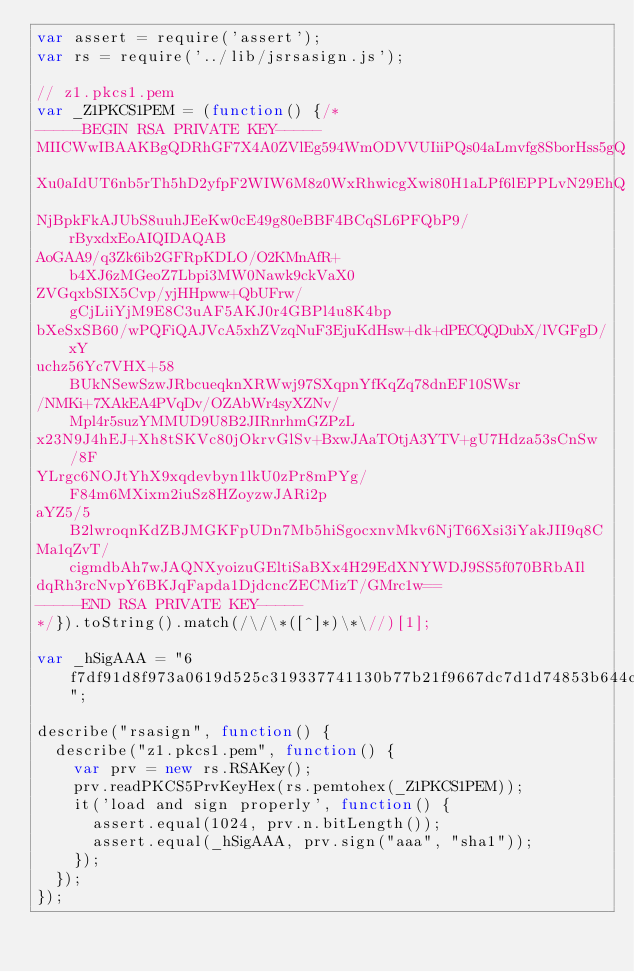<code> <loc_0><loc_0><loc_500><loc_500><_JavaScript_>var assert = require('assert');
var rs = require('../lib/jsrsasign.js');

// z1.pkcs1.pem
var _Z1PKCS1PEM = (function() {/*
-----BEGIN RSA PRIVATE KEY-----
MIICWwIBAAKBgQDRhGF7X4A0ZVlEg594WmODVVUIiiPQs04aLmvfg8SborHss5gQ
Xu0aIdUT6nb5rTh5hD2yfpF2WIW6M8z0WxRhwicgXwi80H1aLPf6lEPPLvN29EhQ
NjBpkFkAJUbS8uuhJEeKw0cE49g80eBBF4BCqSL6PFQbP9/rByxdxEoAIQIDAQAB
AoGAA9/q3Zk6ib2GFRpKDLO/O2KMnAfR+b4XJ6zMGeoZ7Lbpi3MW0Nawk9ckVaX0
ZVGqxbSIX5Cvp/yjHHpww+QbUFrw/gCjLiiYjM9E8C3uAF5AKJ0r4GBPl4u8K4bp
bXeSxSB60/wPQFiQAJVcA5xhZVzqNuF3EjuKdHsw+dk+dPECQQDubX/lVGFgD/xY
uchz56Yc7VHX+58BUkNSewSzwJRbcueqknXRWwj97SXqpnYfKqZq78dnEF10SWsr
/NMKi+7XAkEA4PVqDv/OZAbWr4syXZNv/Mpl4r5suzYMMUD9U8B2JIRnrhmGZPzL
x23N9J4hEJ+Xh8tSKVc80jOkrvGlSv+BxwJAaTOtjA3YTV+gU7Hdza53sCnSw/8F
YLrgc6NOJtYhX9xqdevbyn1lkU0zPr8mPYg/F84m6MXixm2iuSz8HZoyzwJARi2p
aYZ5/5B2lwroqnKdZBJMGKFpUDn7Mb5hiSgocxnvMkv6NjT66Xsi3iYakJII9q8C
Ma1qZvT/cigmdbAh7wJAQNXyoizuGEltiSaBXx4H29EdXNYWDJ9SS5f070BRbAIl
dqRh3rcNvpY6BKJqFapda1DjdcncZECMizT/GMrc1w==
-----END RSA PRIVATE KEY-----
*/}).toString().match(/\/\*([^]*)\*\//)[1];

var _hSigAAA = "6f7df91d8f973a0619d525c319337741130b77b21f9667dc7d1d74853b644cbe5e6b0e84aacc2faee883d43affb811fc653b67c38203d4f206d1b838c4714b6b2cf17cd621303c21bac96090df3883e58784a0576e501c10cdefb12b6bf887e548f6b07b09ae80d8416151d7dab7066d645e2eee57ac5f7af2a70ee0724c8e47";

describe("rsasign", function() {
  describe("z1.pkcs1.pem", function() {
    var prv = new rs.RSAKey();
    prv.readPKCS5PrvKeyHex(rs.pemtohex(_Z1PKCS1PEM));
    it('load and sign properly', function() {
      assert.equal(1024, prv.n.bitLength());
      assert.equal(_hSigAAA, prv.sign("aaa", "sha1"));
    });
  });
});
</code> 